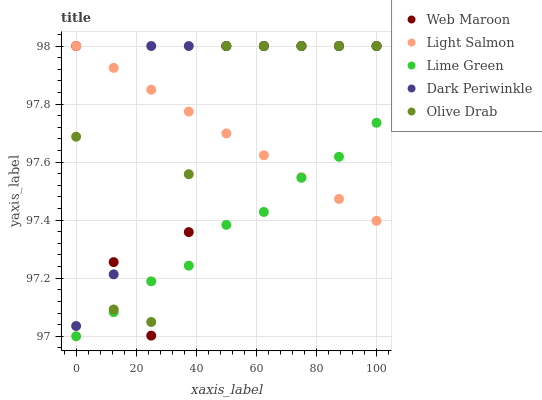Does Lime Green have the minimum area under the curve?
Answer yes or no. Yes. Does Dark Periwinkle have the maximum area under the curve?
Answer yes or no. Yes. Does Light Salmon have the minimum area under the curve?
Answer yes or no. No. Does Light Salmon have the maximum area under the curve?
Answer yes or no. No. Is Light Salmon the smoothest?
Answer yes or no. Yes. Is Web Maroon the roughest?
Answer yes or no. Yes. Is Web Maroon the smoothest?
Answer yes or no. No. Is Light Salmon the roughest?
Answer yes or no. No. Does Lime Green have the lowest value?
Answer yes or no. Yes. Does Web Maroon have the lowest value?
Answer yes or no. No. Does Olive Drab have the highest value?
Answer yes or no. Yes. Is Lime Green less than Dark Periwinkle?
Answer yes or no. Yes. Is Dark Periwinkle greater than Lime Green?
Answer yes or no. Yes. Does Web Maroon intersect Olive Drab?
Answer yes or no. Yes. Is Web Maroon less than Olive Drab?
Answer yes or no. No. Is Web Maroon greater than Olive Drab?
Answer yes or no. No. Does Lime Green intersect Dark Periwinkle?
Answer yes or no. No. 